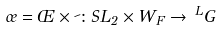<formula> <loc_0><loc_0><loc_500><loc_500>\sigma = \phi \times \psi \colon S L _ { 2 } \times W _ { F } \to \, ^ { L } G</formula> 